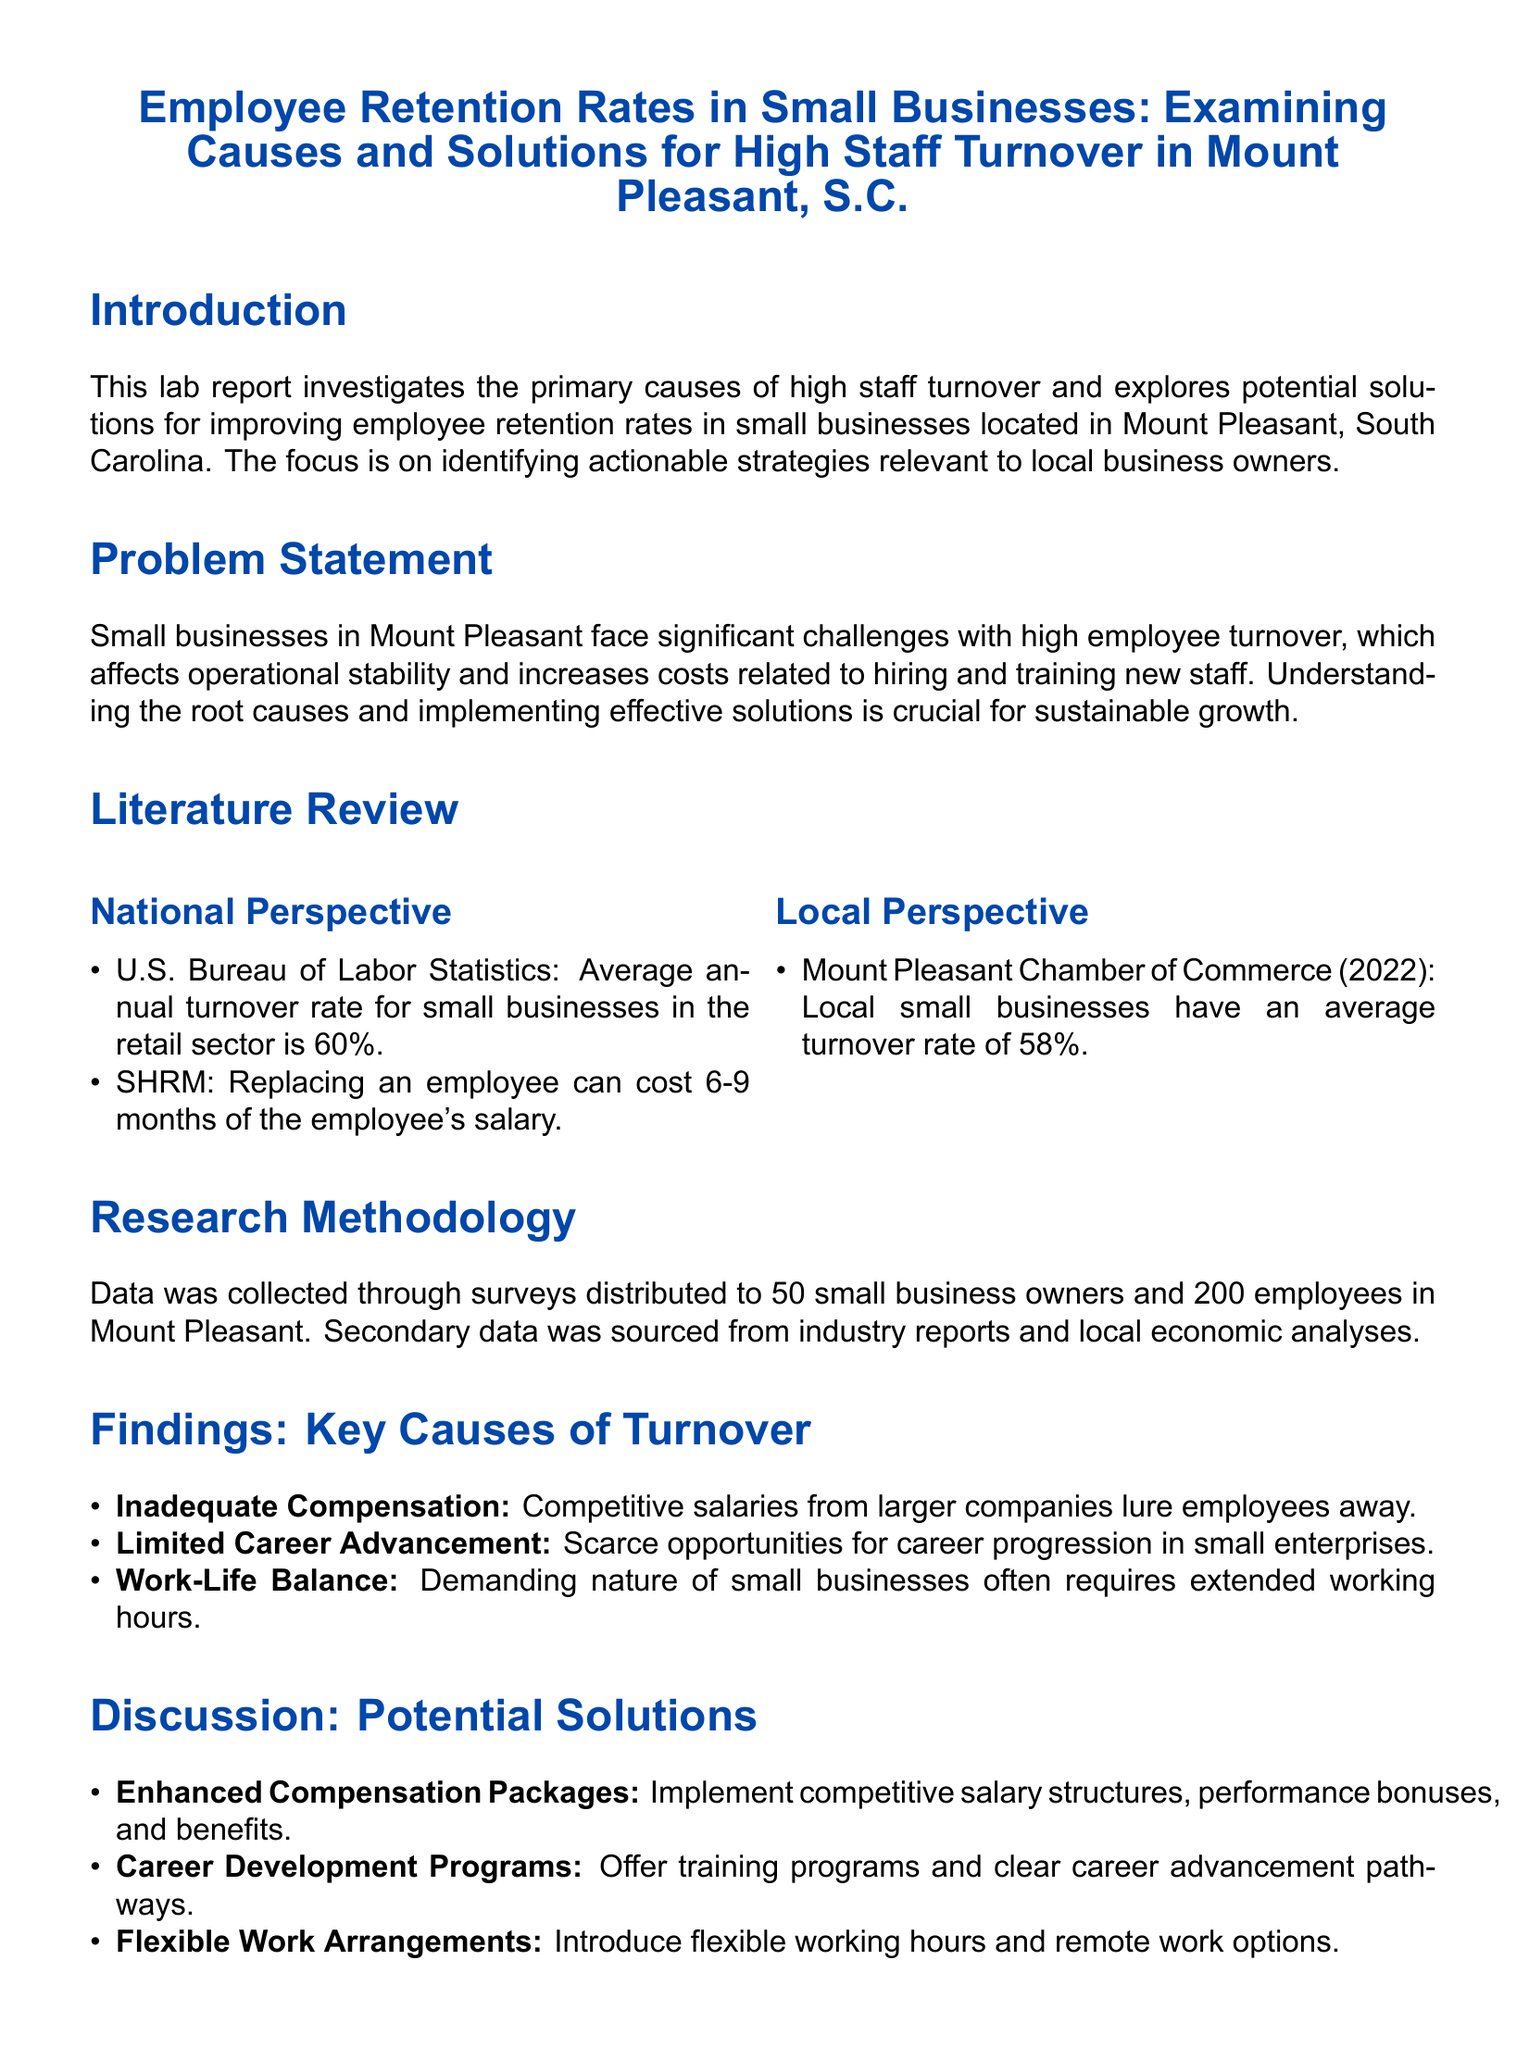What is the average annual turnover rate for small businesses in the retail sector? The average annual turnover rate for small businesses in the retail sector, according to the U.S. Bureau of Labor Statistics, is 60%.
Answer: 60% What is the local average turnover rate for small businesses in Mount Pleasant? The Mount Pleasant Chamber of Commerce reported that local small businesses have an average turnover rate of 58%.
Answer: 58% What is a key cause of turnover related to employee compensation? A key cause of turnover related to employee compensation is inadequate compensation, as competitive salaries from larger companies lure employees away.
Answer: Inadequate Compensation What solution is proposed to address limited career advancement? The proposed solution to address limited career advancement is to offer career development programs and clear career advancement pathways.
Answer: Career Development Programs How many small business owners were surveyed for this report? The report indicates that data was collected through surveys distributed to 50 small business owners.
Answer: 50 What does the report suggest for improving work-life balance? The report suggests introducing flexible working hours and remote work options to improve work-life balance.
Answer: Flexible Work Arrangements What is the main focus of this lab report? The main focus of the lab report is investigating the primary causes of high staff turnover and exploring potential solutions for improving employee retention rates.
Answer: Employee retention rates What organization provided statistics on employee replacement costs? The statistics on employee replacement costs were provided by SHRM.
Answer: SHRM What is the document type of this report? The document type of this report is a lab report.
Answer: Lab report 